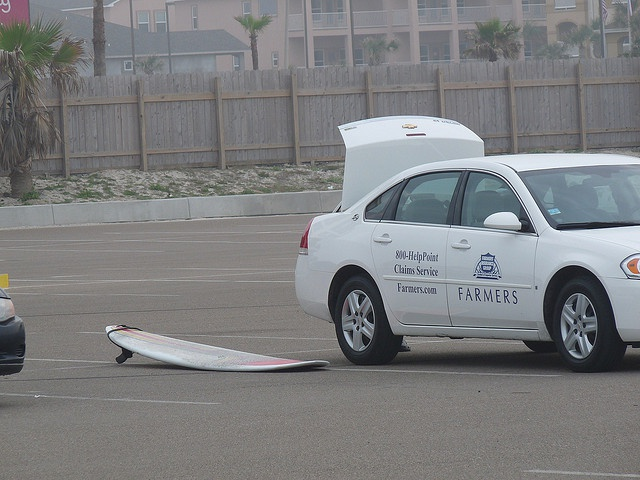Describe the objects in this image and their specific colors. I can see car in brown, darkgray, lightgray, black, and gray tones, surfboard in brown, darkgray, lightgray, gray, and black tones, and car in brown, black, gray, and darkgray tones in this image. 